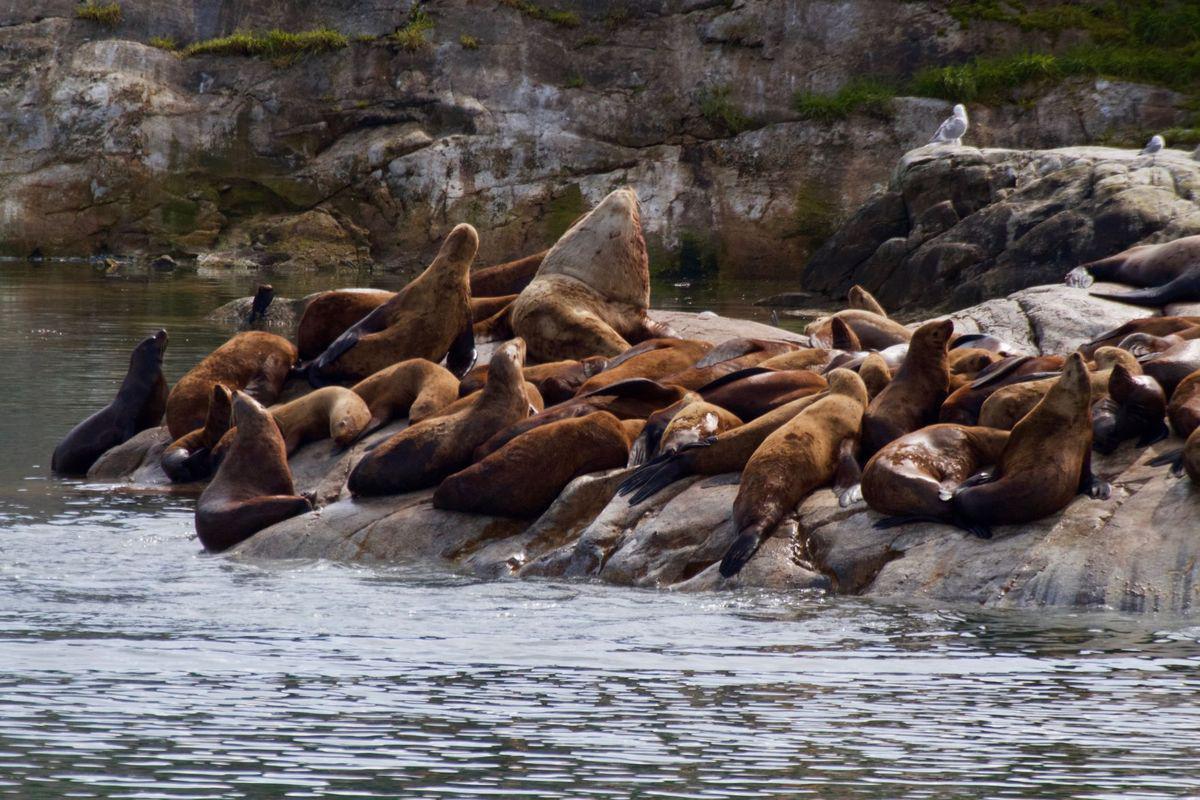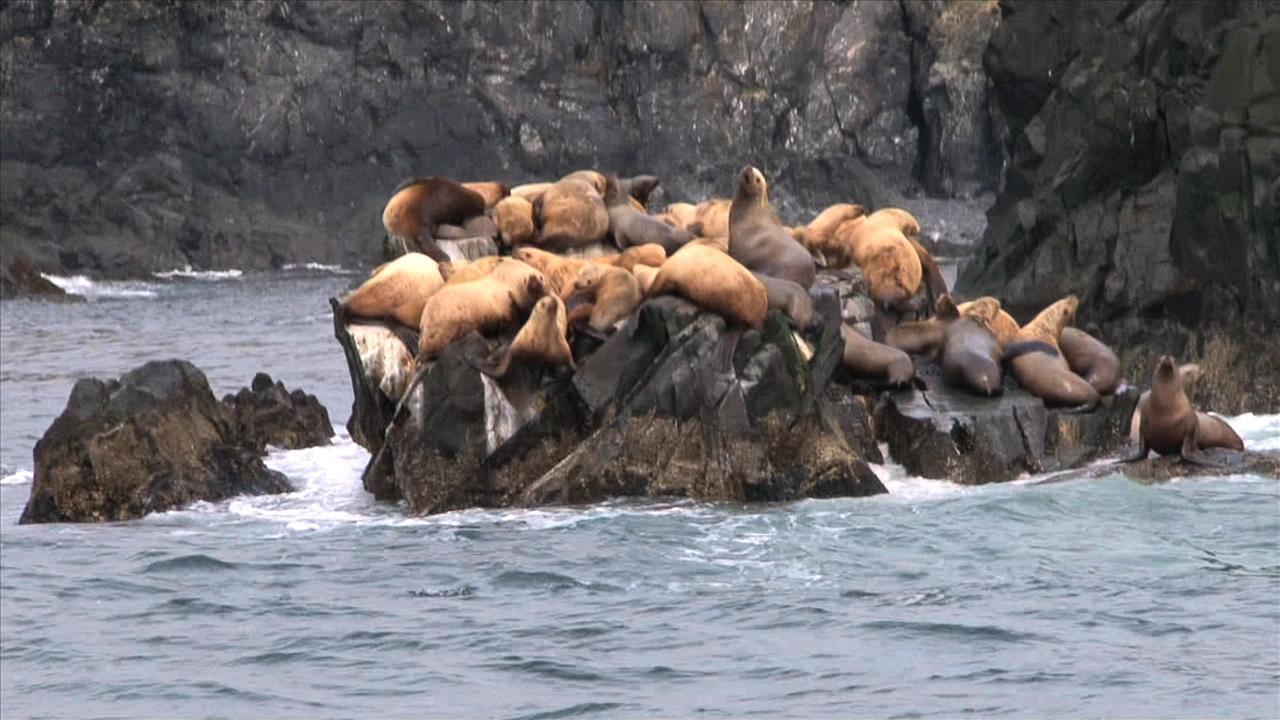The first image is the image on the left, the second image is the image on the right. For the images shown, is this caption "Both images show masses of seals on natural rock formations above the water." true? Answer yes or no. Yes. The first image is the image on the left, the second image is the image on the right. For the images displayed, is the sentence "All seals in the right image are out of the water." factually correct? Answer yes or no. Yes. 